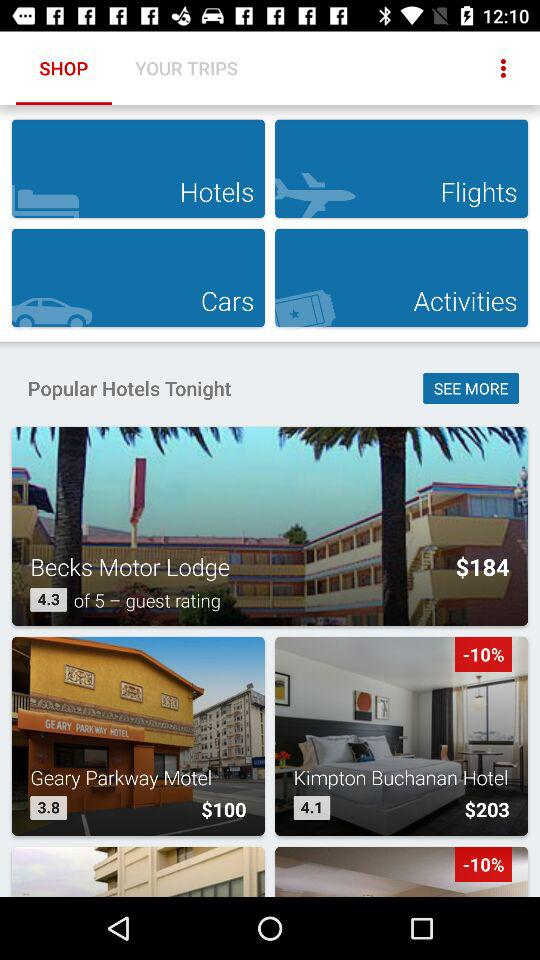What is the guest rating for "Becks Motor Lodge"? The guest rating for "Becks Motor Lodge" is 4.3. 